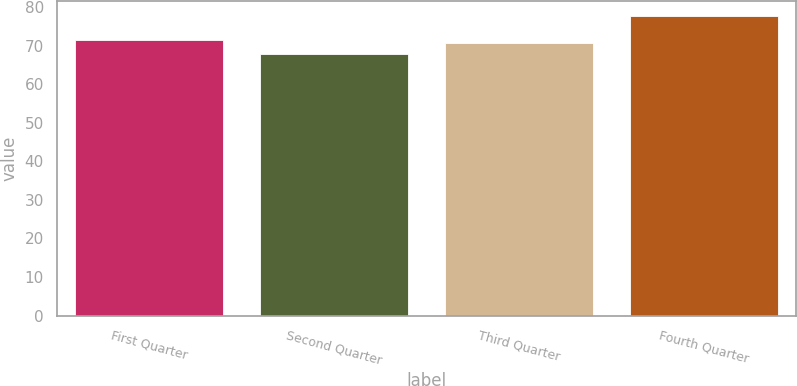Convert chart to OTSL. <chart><loc_0><loc_0><loc_500><loc_500><bar_chart><fcel>First Quarter<fcel>Second Quarter<fcel>Third Quarter<fcel>Fourth Quarter<nl><fcel>71.57<fcel>67.92<fcel>70.6<fcel>77.65<nl></chart> 